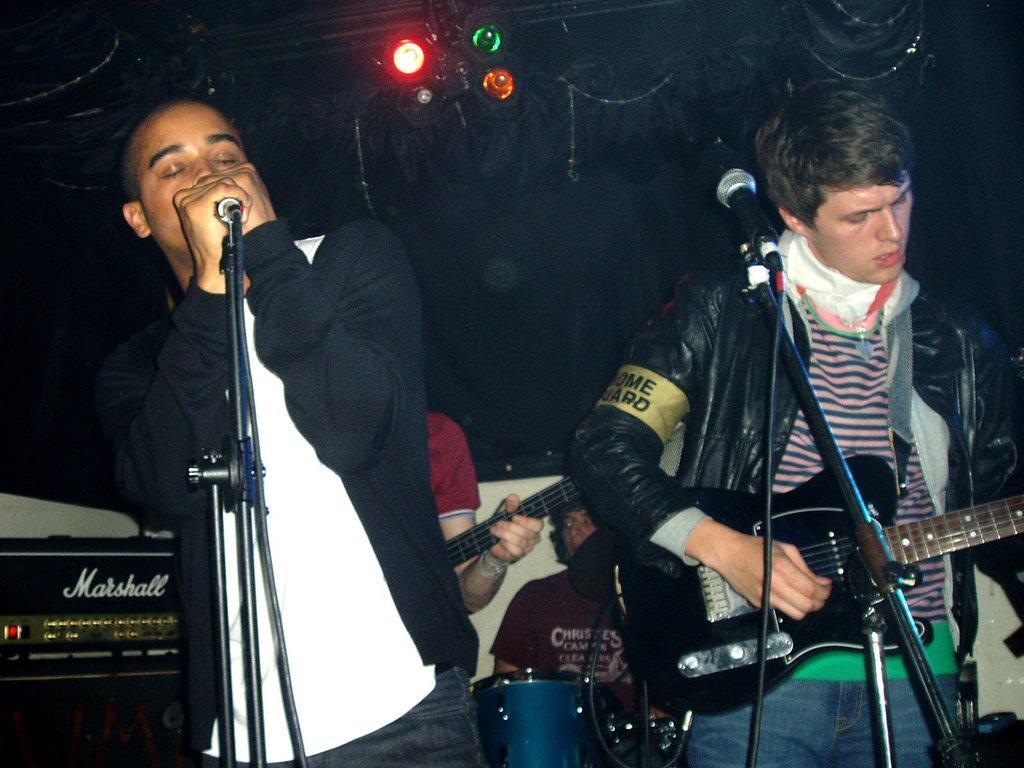In one or two sentences, can you explain what this image depicts? As we can see in the picture that there are two persons standing. The left side one is holding microphone in his hand and singing and the right side one is holding guitar in his hand. This are the lights. 